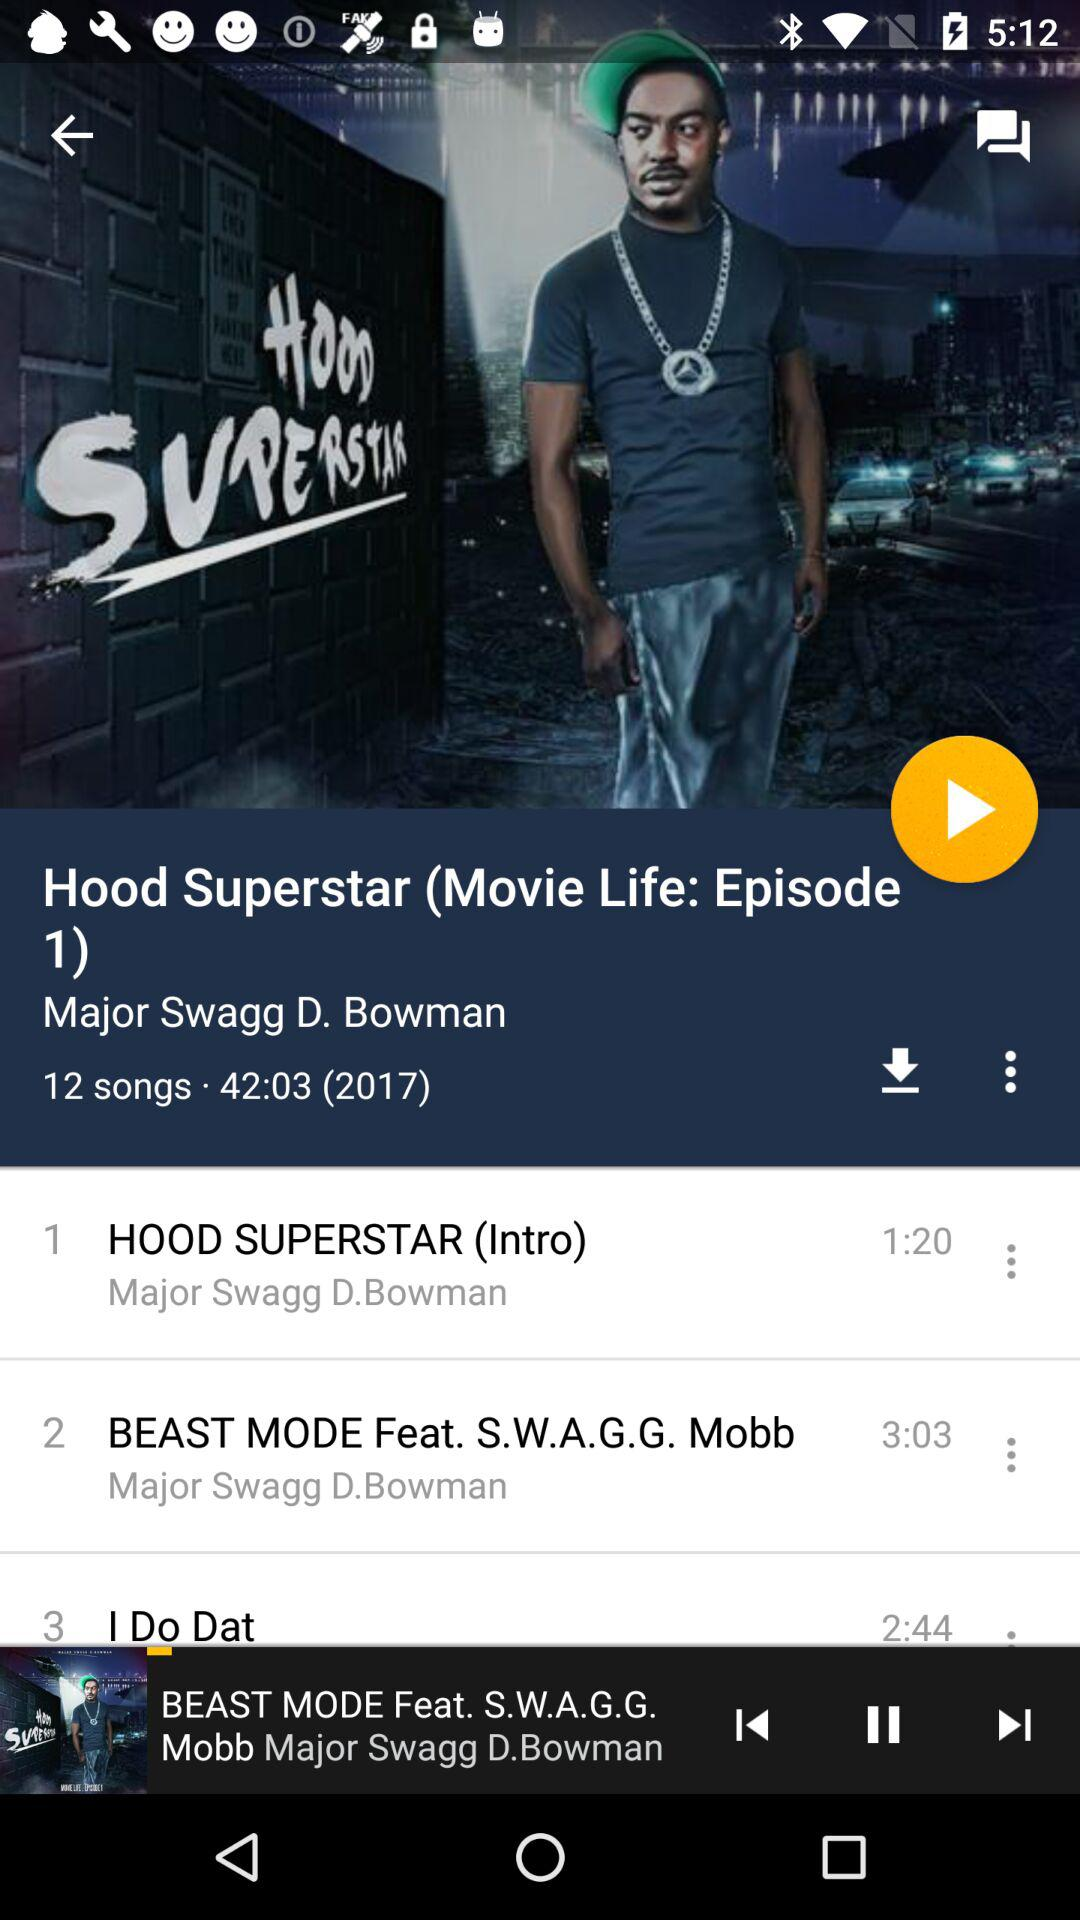How many total songs are there? There are a total of 12 songs. 